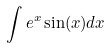<formula> <loc_0><loc_0><loc_500><loc_500>\int e ^ { x } \sin ( x ) d x</formula> 